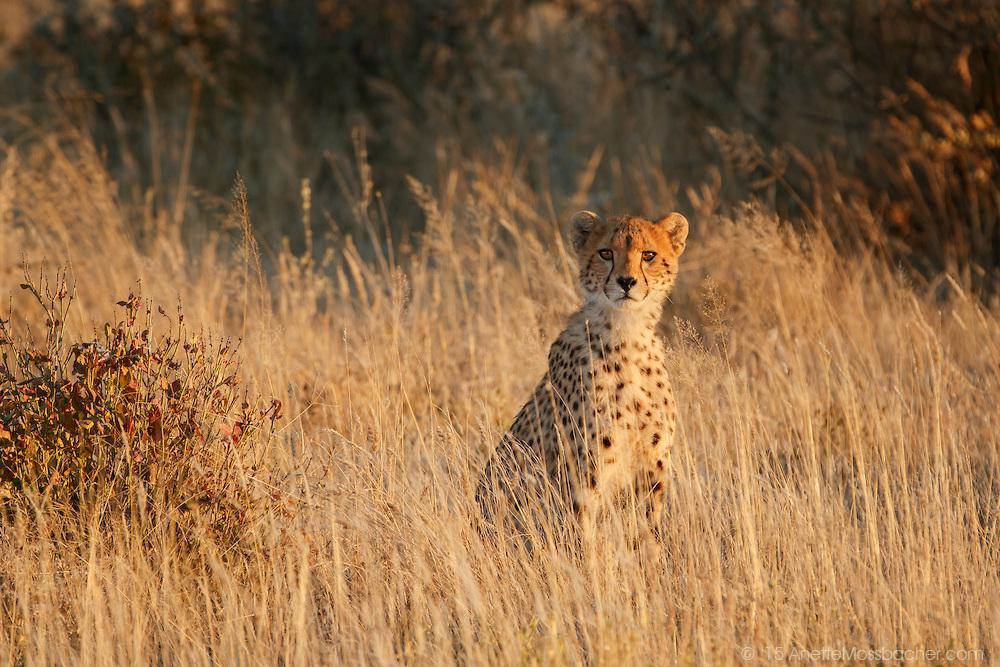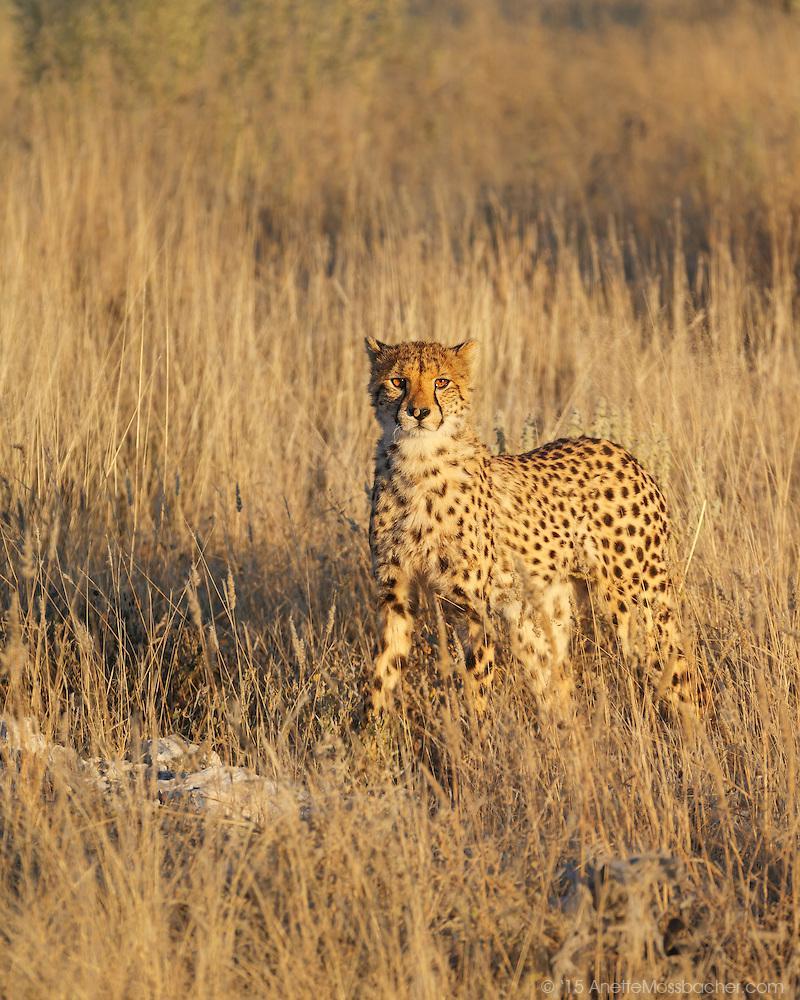The first image is the image on the left, the second image is the image on the right. Examine the images to the left and right. Is the description "Two spotted leopards are standing next to each other." accurate? Answer yes or no. No. The first image is the image on the left, the second image is the image on the right. Assess this claim about the two images: "There is a least one cheetah in each image peering out through the tall grass.". Correct or not? Answer yes or no. Yes. 